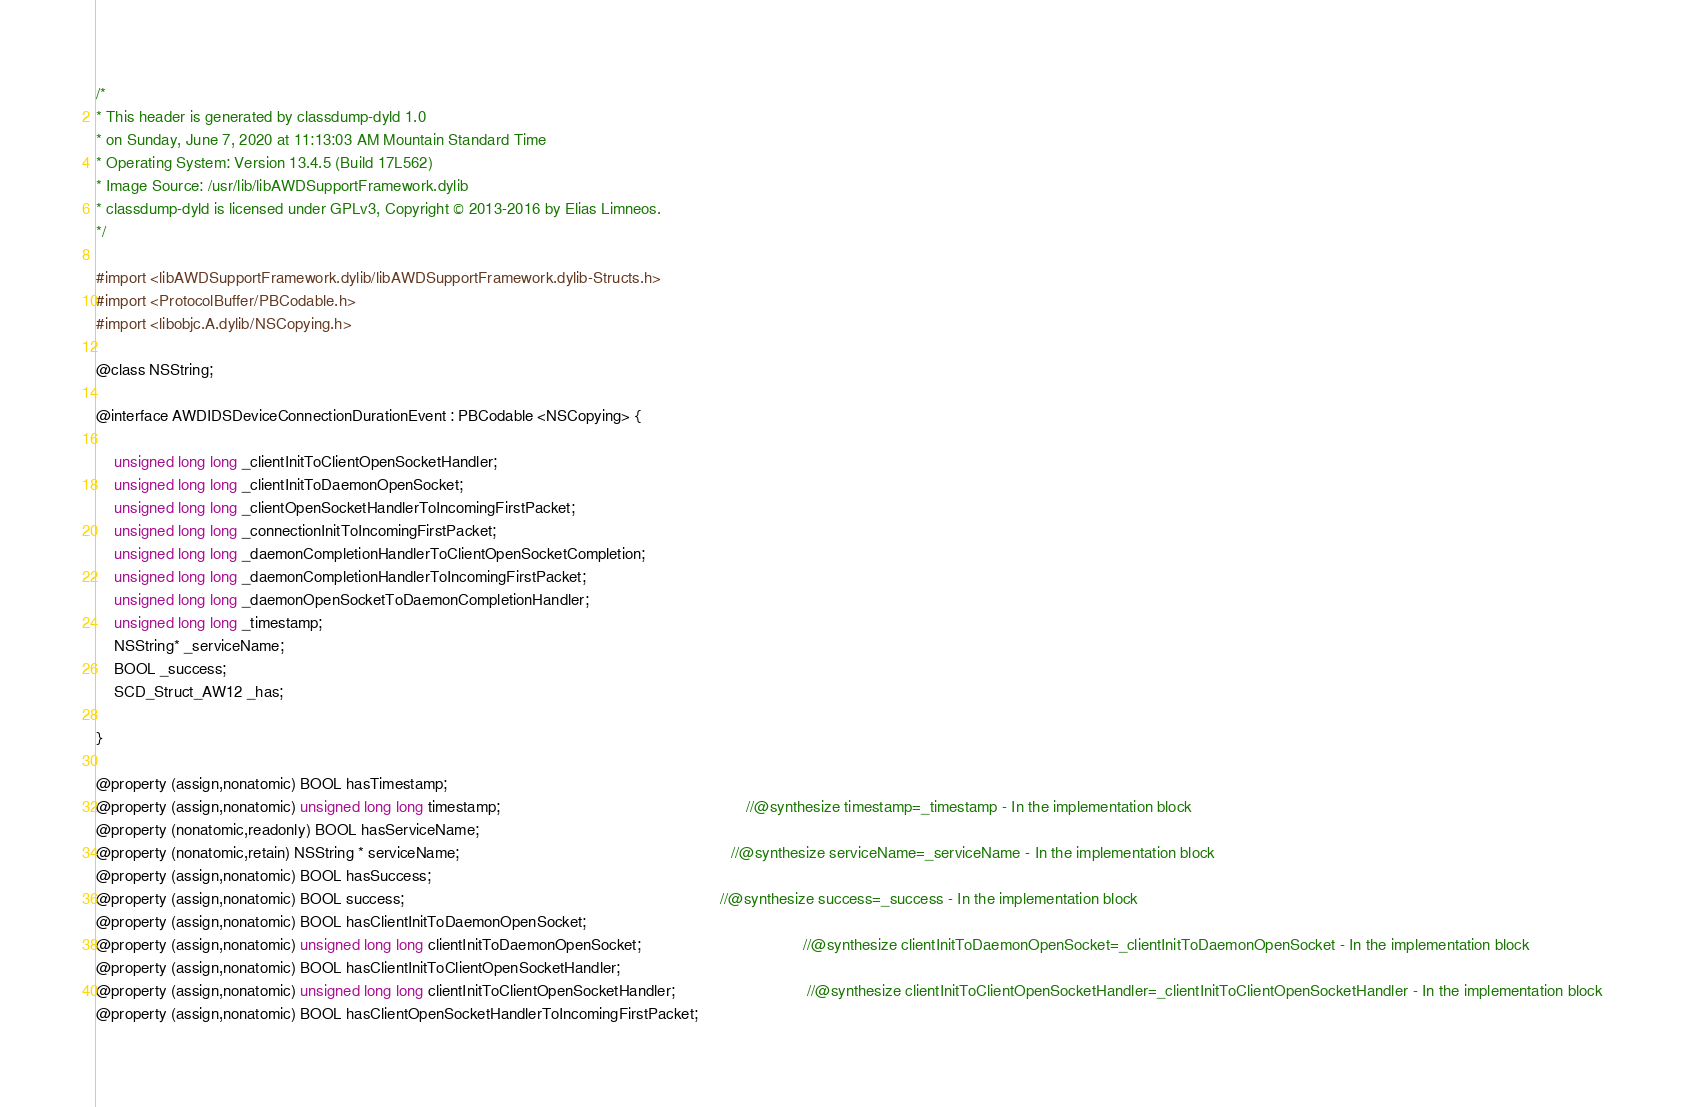Convert code to text. <code><loc_0><loc_0><loc_500><loc_500><_C_>/*
* This header is generated by classdump-dyld 1.0
* on Sunday, June 7, 2020 at 11:13:03 AM Mountain Standard Time
* Operating System: Version 13.4.5 (Build 17L562)
* Image Source: /usr/lib/libAWDSupportFramework.dylib
* classdump-dyld is licensed under GPLv3, Copyright © 2013-2016 by Elias Limneos.
*/

#import <libAWDSupportFramework.dylib/libAWDSupportFramework.dylib-Structs.h>
#import <ProtocolBuffer/PBCodable.h>
#import <libobjc.A.dylib/NSCopying.h>

@class NSString;

@interface AWDIDSDeviceConnectionDurationEvent : PBCodable <NSCopying> {

	unsigned long long _clientInitToClientOpenSocketHandler;
	unsigned long long _clientInitToDaemonOpenSocket;
	unsigned long long _clientOpenSocketHandlerToIncomingFirstPacket;
	unsigned long long _connectionInitToIncomingFirstPacket;
	unsigned long long _daemonCompletionHandlerToClientOpenSocketCompletion;
	unsigned long long _daemonCompletionHandlerToIncomingFirstPacket;
	unsigned long long _daemonOpenSocketToDaemonCompletionHandler;
	unsigned long long _timestamp;
	NSString* _serviceName;
	BOOL _success;
	SCD_Struct_AW12 _has;

}

@property (assign,nonatomic) BOOL hasTimestamp; 
@property (assign,nonatomic) unsigned long long timestamp;                                                        //@synthesize timestamp=_timestamp - In the implementation block
@property (nonatomic,readonly) BOOL hasServiceName; 
@property (nonatomic,retain) NSString * serviceName;                                                              //@synthesize serviceName=_serviceName - In the implementation block
@property (assign,nonatomic) BOOL hasSuccess; 
@property (assign,nonatomic) BOOL success;                                                                        //@synthesize success=_success - In the implementation block
@property (assign,nonatomic) BOOL hasClientInitToDaemonOpenSocket; 
@property (assign,nonatomic) unsigned long long clientInitToDaemonOpenSocket;                                     //@synthesize clientInitToDaemonOpenSocket=_clientInitToDaemonOpenSocket - In the implementation block
@property (assign,nonatomic) BOOL hasClientInitToClientOpenSocketHandler; 
@property (assign,nonatomic) unsigned long long clientInitToClientOpenSocketHandler;                              //@synthesize clientInitToClientOpenSocketHandler=_clientInitToClientOpenSocketHandler - In the implementation block
@property (assign,nonatomic) BOOL hasClientOpenSocketHandlerToIncomingFirstPacket; </code> 